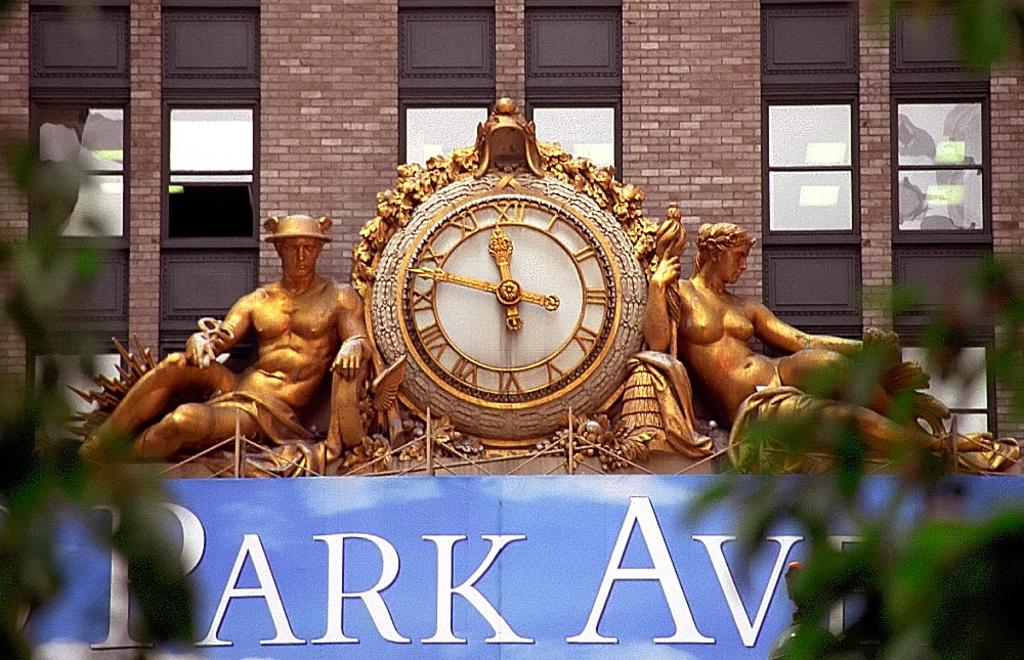Is it before noon on the clock?
Your answer should be very brief. Yes. What time does the clock say?
Your answer should be compact. 11:48. 